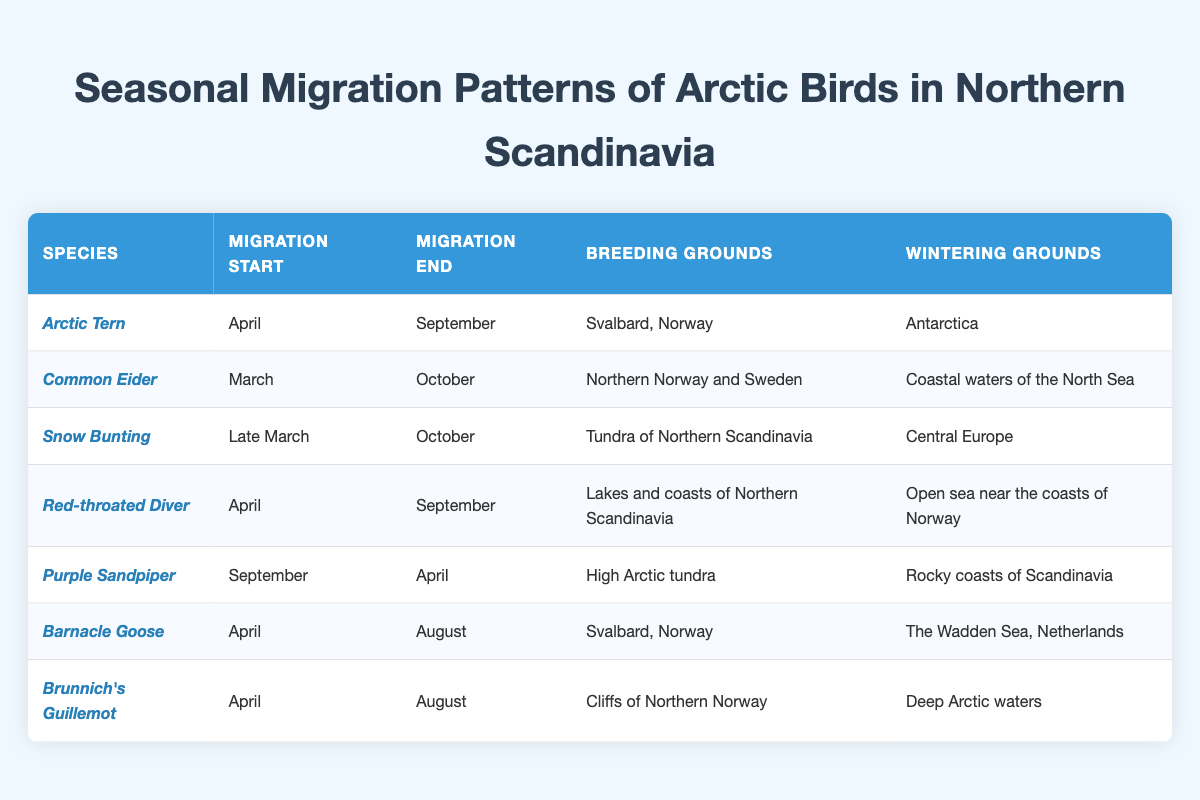What species has the earliest migration start? From the table, the earliest migration start is in March for the Common Eider. This is the only entry that starts in March, making it the earliest species listed.
Answer: Common Eider Which species migrates to Antarctica for winter? The Arctic Tern is the only species that migrates to Antarctica for winter. This is found in the fourth column of the table under wintering grounds.
Answer: Arctic Tern How long is the migration period for the Barnacle Goose? The Barnacle Goose migrates from April to August. To find the duration, we count the months: April, May, June, July, and August, totaling five months.
Answer: 5 months Is the Red-throated Diver’s breeding ground located in Northern Scandinavia? Yes, the breeding grounds for the Red-throated Diver are listed as Lakes and coasts of Northern Scandinavia, confirming that it breeds there.
Answer: Yes Which species migrates in both spring and autumn? The Snow Bunting migrates from late March to October, indicating that it migrates during both spring (starting in March) and autumn (ending in October). Other species either only migrate in spring or autumn.
Answer: Snow Bunting What are the wintering grounds for the Purple Sandpiper? The wintering grounds for the Purple Sandpiper are the Rocky coasts of Scandinavia, as stated in the last column of the table.
Answer: Rocky coasts of Scandinavia How do the migration periods compare for the Arctic Tern and the Red-throated Diver? The Arctic Tern migrates from April to September (5 months), while the Red-throated Diver migrates from April to September as well (5 months). They have the same duration for their migration periods.
Answer: They are the same (5 months) Which species has wintering grounds in Central Europe? The Snow Bunting is indicated to have its wintering grounds in Central Europe, as shown in the table. This is the only entry linking a species to that region for wintering.
Answer: Snow Bunting What is the commonality in the migration start months for Arctic Tern, Red-throated Diver, Barnacle Goose, and Brunnich's Guillemot? All these species start their migration in April. They share the same starting month, making this a common characteristic among them.
Answer: April Count the number of species that have migration periods that extend into October. The species that extend their migration into October are Common Eider and Snow Bunting. The count confirms that there are two species that migrate until October.
Answer: 2 